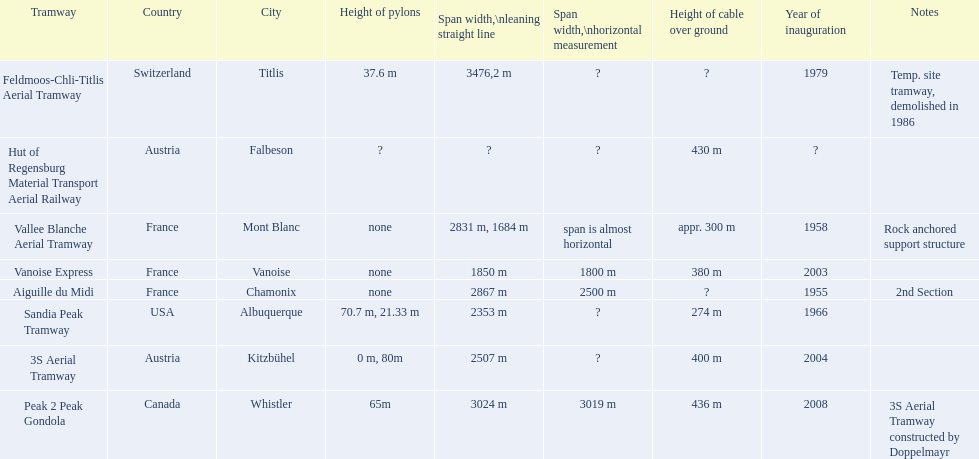Which tramways are in france? Vanoise Express, Aiguille du Midi, Vallee Blanche Aerial Tramway. Which of those were inaugurated in the 1950? Aiguille du Midi, Vallee Blanche Aerial Tramway. Which of these tramways span is not almost horizontal? Aiguille du Midi. 